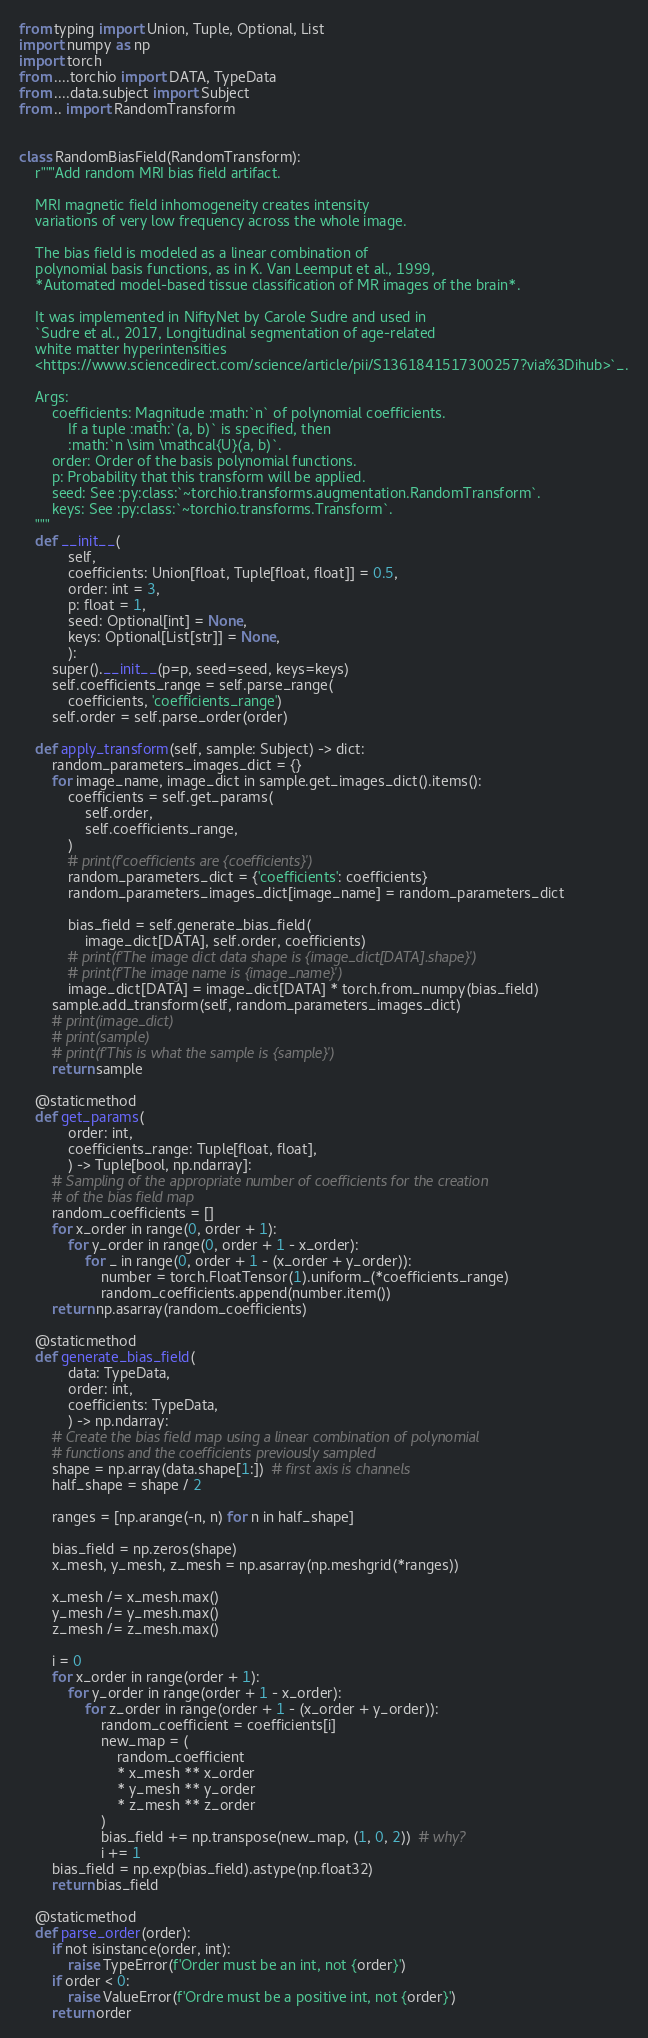Convert code to text. <code><loc_0><loc_0><loc_500><loc_500><_Python_>
from typing import Union, Tuple, Optional, List
import numpy as np
import torch
from ....torchio import DATA, TypeData
from ....data.subject import Subject
from .. import RandomTransform


class RandomBiasField(RandomTransform):
    r"""Add random MRI bias field artifact.

    MRI magnetic field inhomogeneity creates intensity
    variations of very low frequency across the whole image.

    The bias field is modeled as a linear combination of
    polynomial basis functions, as in K. Van Leemput et al., 1999,
    *Automated model-based tissue classification of MR images of the brain*.

    It was implemented in NiftyNet by Carole Sudre and used in
    `Sudre et al., 2017, Longitudinal segmentation of age-related
    white matter hyperintensities
    <https://www.sciencedirect.com/science/article/pii/S1361841517300257?via%3Dihub>`_.

    Args:
        coefficients: Magnitude :math:`n` of polynomial coefficients.
            If a tuple :math:`(a, b)` is specified, then
            :math:`n \sim \mathcal{U}(a, b)`.
        order: Order of the basis polynomial functions.
        p: Probability that this transform will be applied.
        seed: See :py:class:`~torchio.transforms.augmentation.RandomTransform`.
        keys: See :py:class:`~torchio.transforms.Transform`.
    """
    def __init__(
            self,
            coefficients: Union[float, Tuple[float, float]] = 0.5,
            order: int = 3,
            p: float = 1,
            seed: Optional[int] = None,
            keys: Optional[List[str]] = None,
            ):
        super().__init__(p=p, seed=seed, keys=keys)
        self.coefficients_range = self.parse_range(
            coefficients, 'coefficients_range')
        self.order = self.parse_order(order)

    def apply_transform(self, sample: Subject) -> dict:
        random_parameters_images_dict = {}
        for image_name, image_dict in sample.get_images_dict().items():
            coefficients = self.get_params(
                self.order,
                self.coefficients_range,
            )
            # print(f'coefficients are {coefficients}')
            random_parameters_dict = {'coefficients': coefficients}
            random_parameters_images_dict[image_name] = random_parameters_dict

            bias_field = self.generate_bias_field(
                image_dict[DATA], self.order, coefficients)
            # print(f'The image dict data shape is {image_dict[DATA].shape}')
            # print(f'The image name is {image_name}')
            image_dict[DATA] = image_dict[DATA] * torch.from_numpy(bias_field)
        sample.add_transform(self, random_parameters_images_dict)
        # print(image_dict)
        # print(sample)
        # print(f'This is what the sample is {sample}')
        return sample

    @staticmethod
    def get_params(
            order: int,
            coefficients_range: Tuple[float, float],
            ) -> Tuple[bool, np.ndarray]:
        # Sampling of the appropriate number of coefficients for the creation
        # of the bias field map
        random_coefficients = []
        for x_order in range(0, order + 1):
            for y_order in range(0, order + 1 - x_order):
                for _ in range(0, order + 1 - (x_order + y_order)):
                    number = torch.FloatTensor(1).uniform_(*coefficients_range)
                    random_coefficients.append(number.item())
        return np.asarray(random_coefficients)

    @staticmethod
    def generate_bias_field(
            data: TypeData,
            order: int,
            coefficients: TypeData,
            ) -> np.ndarray:
        # Create the bias field map using a linear combination of polynomial
        # functions and the coefficients previously sampled
        shape = np.array(data.shape[1:])  # first axis is channels
        half_shape = shape / 2

        ranges = [np.arange(-n, n) for n in half_shape]

        bias_field = np.zeros(shape)
        x_mesh, y_mesh, z_mesh = np.asarray(np.meshgrid(*ranges))

        x_mesh /= x_mesh.max()
        y_mesh /= y_mesh.max()
        z_mesh /= z_mesh.max()

        i = 0
        for x_order in range(order + 1):
            for y_order in range(order + 1 - x_order):
                for z_order in range(order + 1 - (x_order + y_order)):
                    random_coefficient = coefficients[i]
                    new_map = (
                        random_coefficient
                        * x_mesh ** x_order
                        * y_mesh ** y_order
                        * z_mesh ** z_order
                    )
                    bias_field += np.transpose(new_map, (1, 0, 2))  # why?
                    i += 1
        bias_field = np.exp(bias_field).astype(np.float32)
        return bias_field

    @staticmethod
    def parse_order(order):
        if not isinstance(order, int):
            raise TypeError(f'Order must be an int, not {order}')
        if order < 0:
            raise ValueError(f'Ordre must be a positive int, not {order}')
        return order
</code> 